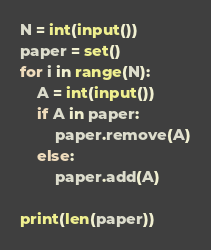Convert code to text. <code><loc_0><loc_0><loc_500><loc_500><_Python_>N = int(input())
paper = set()
for i in range(N):
    A = int(input())
    if A in paper:
        paper.remove(A)
    else:
        paper.add(A)

print(len(paper))
</code> 